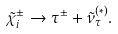<formula> <loc_0><loc_0><loc_500><loc_500>\tilde { \chi } _ { i } ^ { \pm } \to \tau ^ { \pm } + \tilde { \nu } ^ { ( \ast ) } _ { \tau } .</formula> 